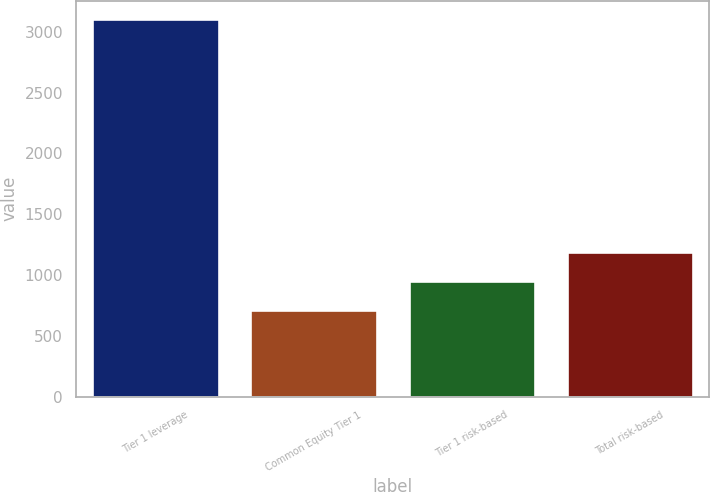Convert chart to OTSL. <chart><loc_0><loc_0><loc_500><loc_500><bar_chart><fcel>Tier 1 leverage<fcel>Common Equity Tier 1<fcel>Tier 1 risk-based<fcel>Total risk-based<nl><fcel>3101<fcel>713<fcel>951.8<fcel>1190.6<nl></chart> 